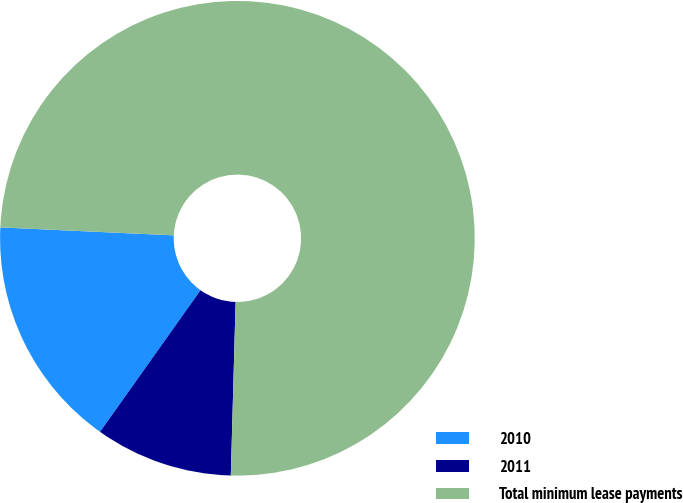Convert chart. <chart><loc_0><loc_0><loc_500><loc_500><pie_chart><fcel>2010<fcel>2011<fcel>Total minimum lease payments<nl><fcel>15.91%<fcel>9.38%<fcel>74.71%<nl></chart> 